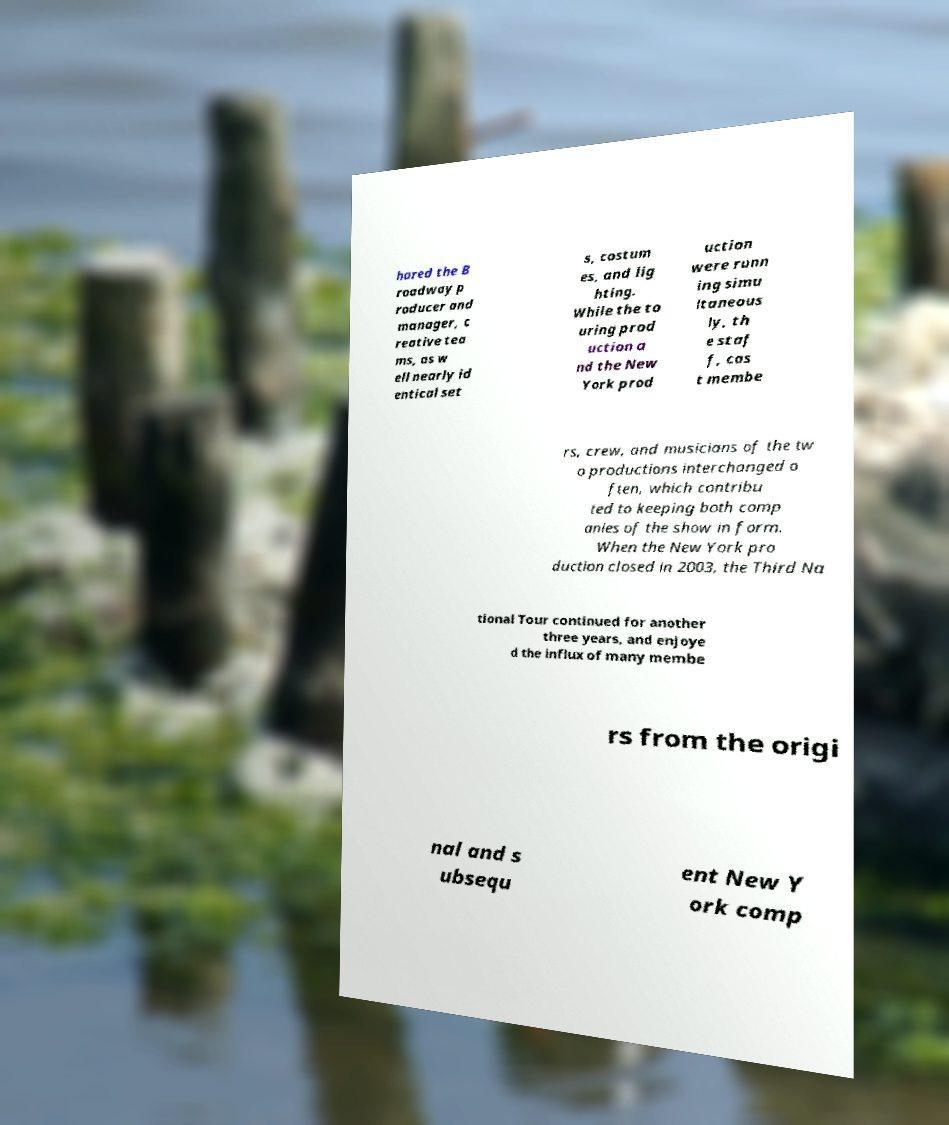I need the written content from this picture converted into text. Can you do that? hared the B roadway p roducer and manager, c reative tea ms, as w ell nearly id entical set s, costum es, and lig hting. While the to uring prod uction a nd the New York prod uction were runn ing simu ltaneous ly, th e staf f, cas t membe rs, crew, and musicians of the tw o productions interchanged o ften, which contribu ted to keeping both comp anies of the show in form. When the New York pro duction closed in 2003, the Third Na tional Tour continued for another three years, and enjoye d the influx of many membe rs from the origi nal and s ubsequ ent New Y ork comp 